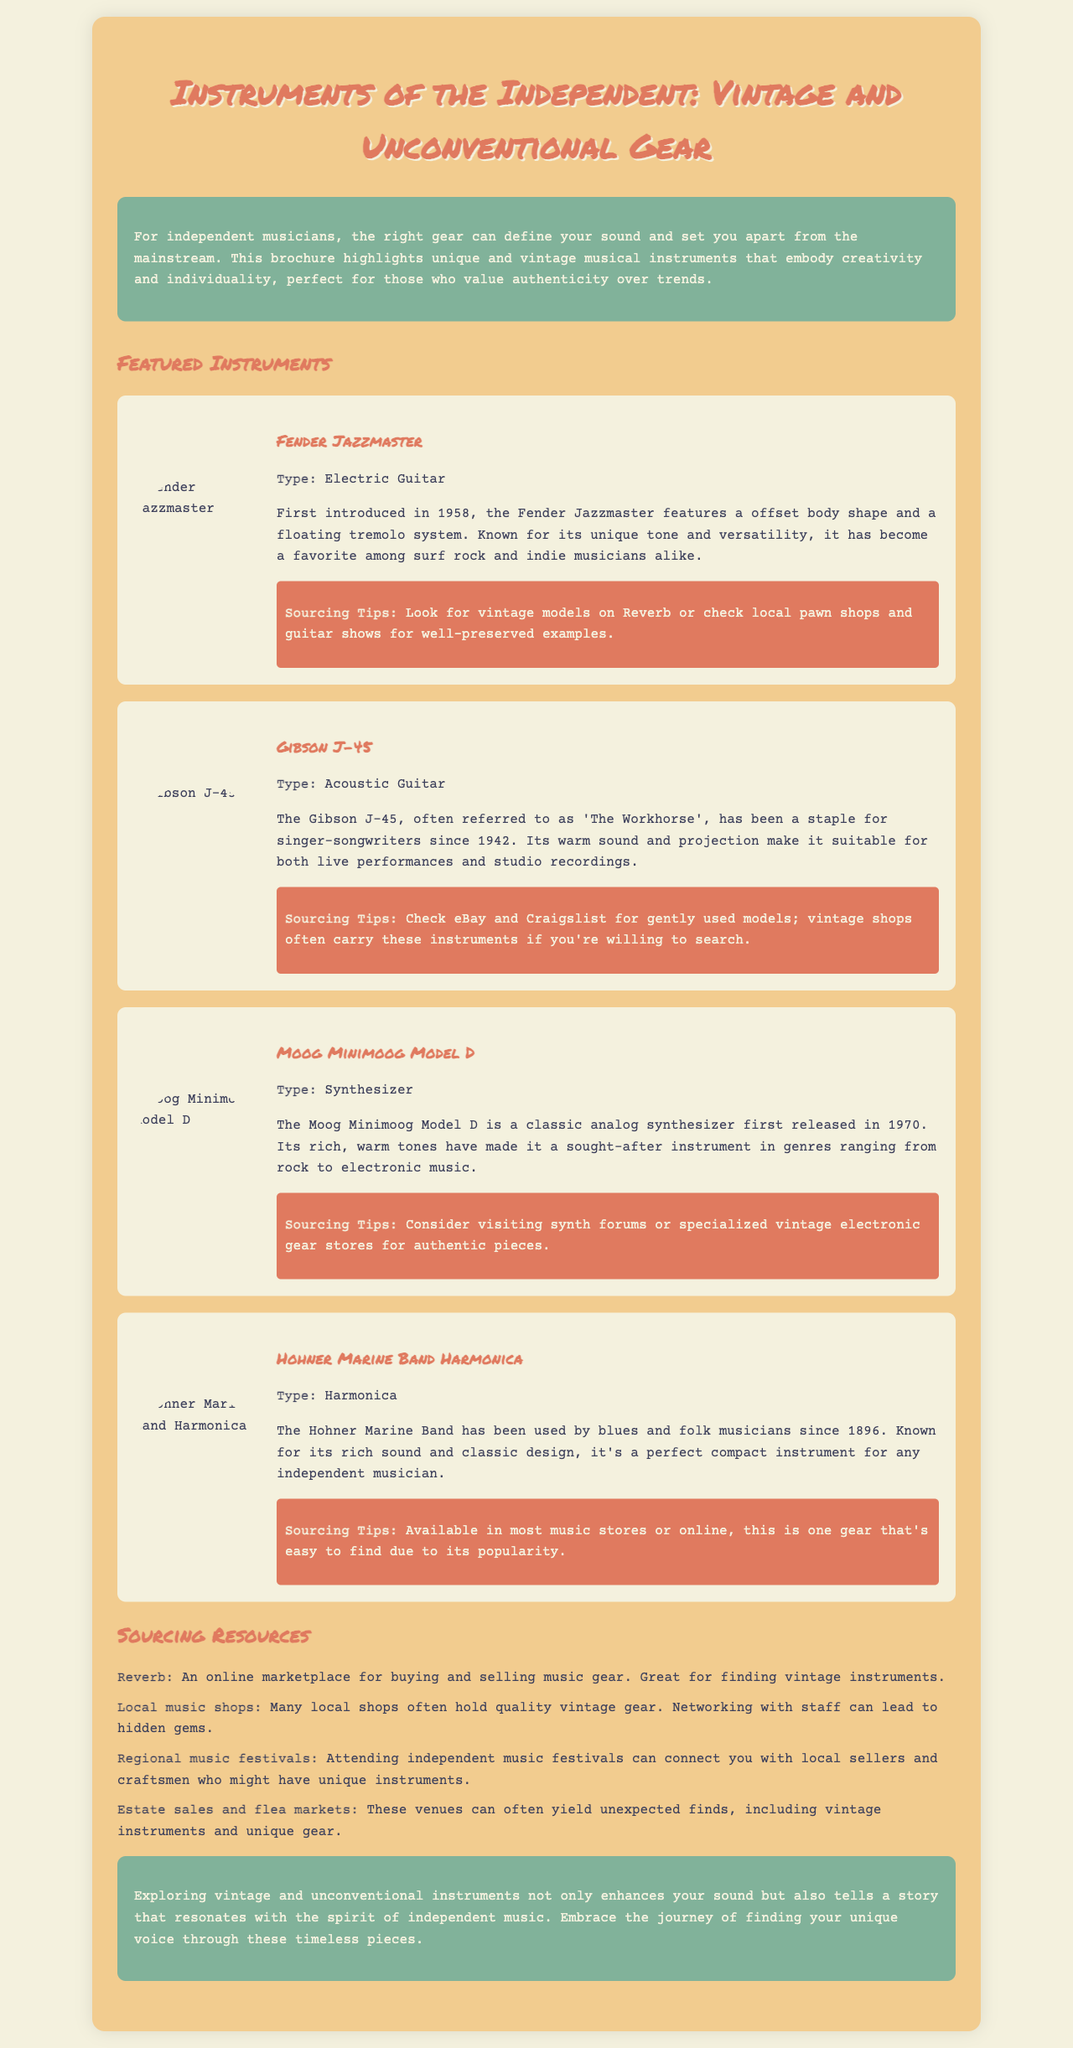What is the title of the brochure? The title of the brochure is prominently displayed at the top, indicating the focus on vintage and unconventional gear.
Answer: Instruments of the Independent: Vintage and Unconventional Gear When was the Fender Jazzmaster first introduced? The introduction year of the Fender Jazzmaster is mentioned in the instrument description section.
Answer: 1958 What instrument type is the Gibson J-45? The document specifies the type of the Gibson J-45 acoustic guitar in its description.
Answer: Acoustic Guitar Which synthesizer is known for its rich, warm tones? The document describes the Moog Minimoog Model D as having rich, warm tones, making it a sought-after instrument.
Answer: Moog Minimoog Model D Where can one find the Hohner Marine Band Harmonica? The sourcing tips inform where to find the Hohner Marine Band Harmonica.
Answer: Most music stores or online What resource specializes in buying and selling music gear? The brochure lists Reverb as an online marketplace for music gear.
Answer: Reverb What are regional music festivals good for? The document notes that regional music festivals can connect musicians with local sellers and craftsmen.
Answer: Connecting with local sellers and craftsmen What instrument was first released in 1970? The release year of the Moog Minimoog Model D is stated in the instrument description.
Answer: 1970 